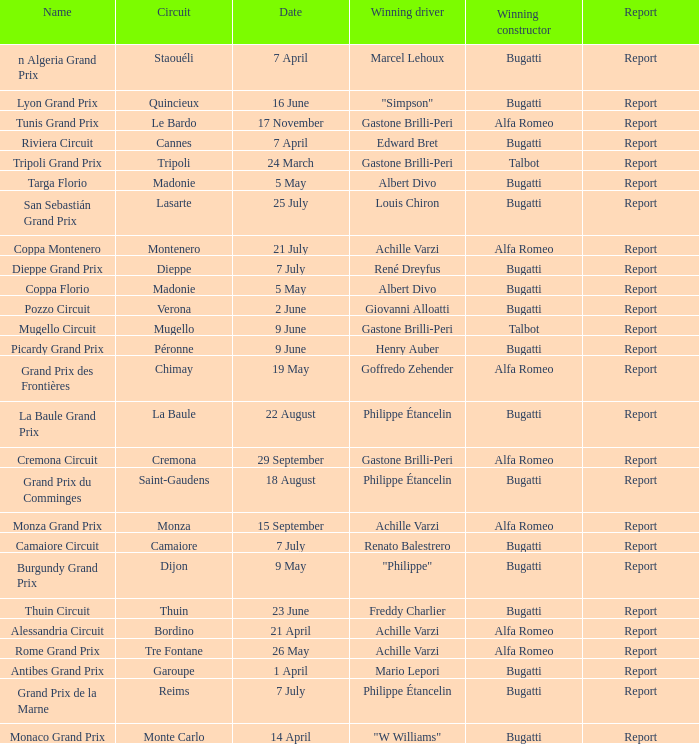What Date has a Name of thuin circuit? 23 June. 